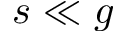Convert formula to latex. <formula><loc_0><loc_0><loc_500><loc_500>s \ll g</formula> 